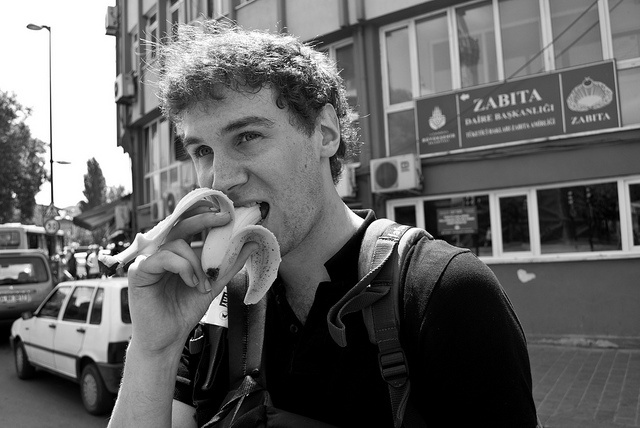Describe the objects in this image and their specific colors. I can see people in white, black, gray, darkgray, and gainsboro tones, car in white, black, darkgray, lightgray, and gray tones, backpack in white, black, lightgray, darkgray, and gray tones, banana in white, darkgray, gray, lightgray, and black tones, and car in white, gray, black, darkgray, and lightgray tones in this image. 